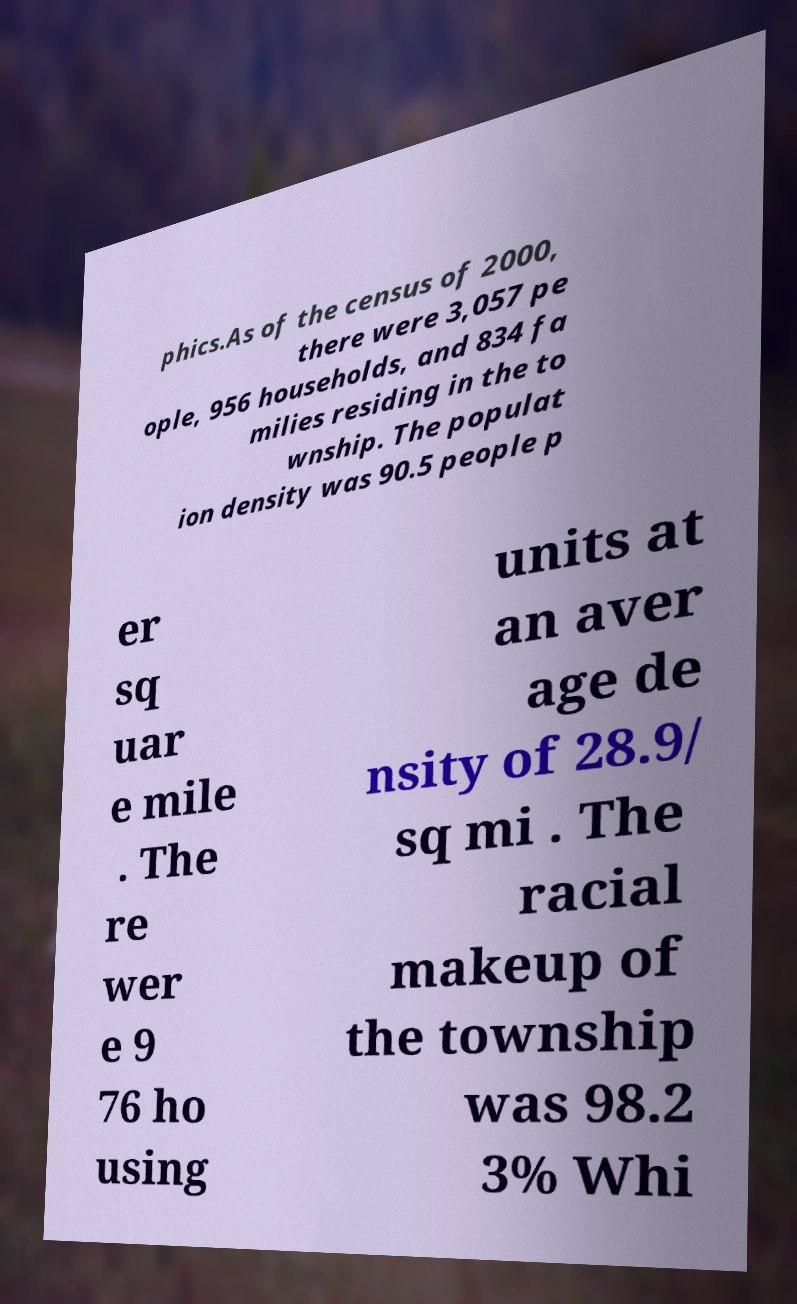Could you assist in decoding the text presented in this image and type it out clearly? phics.As of the census of 2000, there were 3,057 pe ople, 956 households, and 834 fa milies residing in the to wnship. The populat ion density was 90.5 people p er sq uar e mile . The re wer e 9 76 ho using units at an aver age de nsity of 28.9/ sq mi . The racial makeup of the township was 98.2 3% Whi 